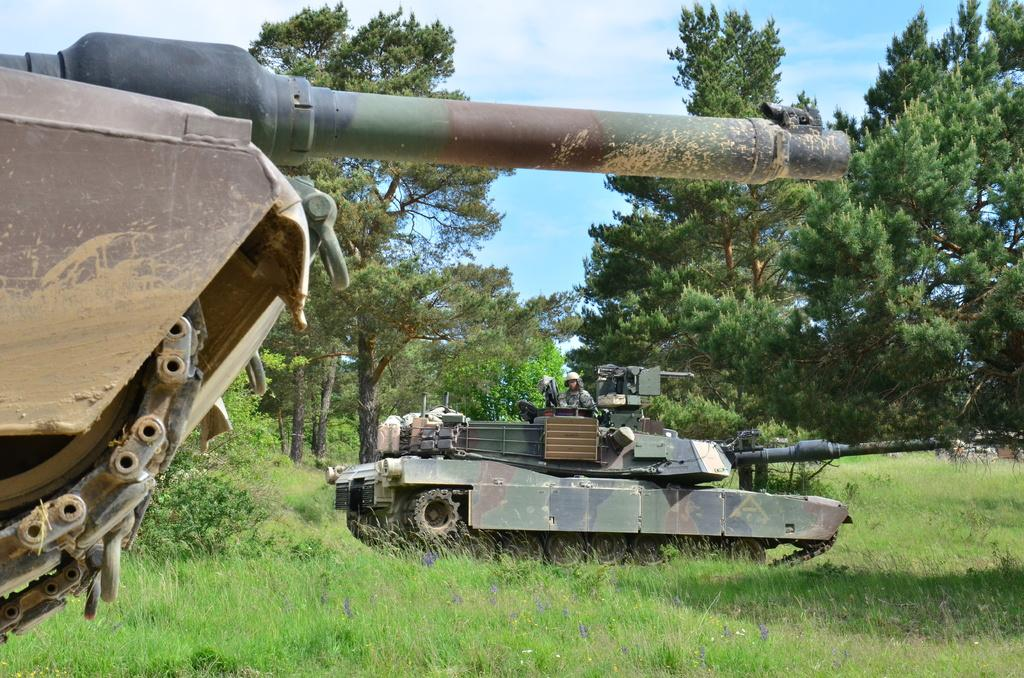What type of vehicles are present in the image? There are war tanks in the image. How are the war tanks positioned in the image? The war tanks are standing on the ground. Is there anyone inside the war tanks? Yes, there is a person sitting in one of the war tanks. What can be seen in the background of the image? There are trees visible in the background of the image. What is the ground covered with in the image? The ground is covered with grass. What type of stocking is hanging from the war tank in the image? There is no stocking hanging from the war tank in the image. What is the best way to approach the war tanks in the image? The question of the best way to approach the war tanks cannot be answered definitively from the image alone, as it depends on various factors such as safety and context. 